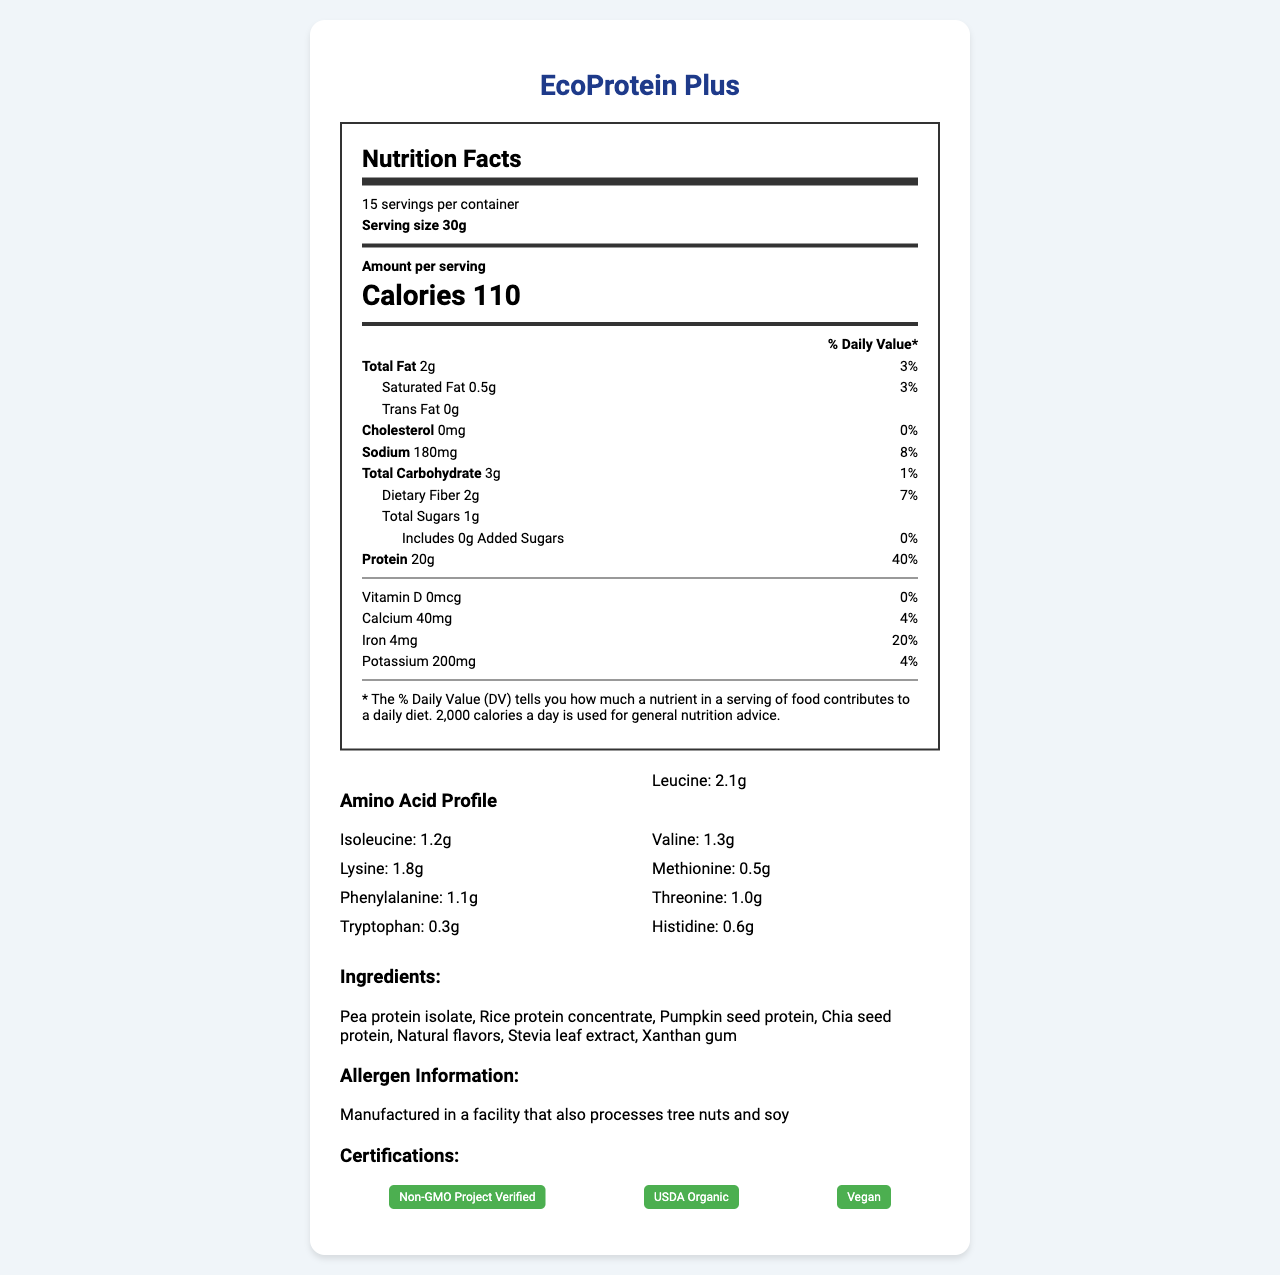what is the serving size of EcoProtein Plus? The serving size is explicitly mentioned on the label as 30g.
Answer: 30g how many servings are there per container? According to the label, there are 15 servings per container.
Answer: 15 how many calories per serving? The label specifies that there are 110 calories per serving.
Answer: 110 what is the amount of protein per serving? The protein amount per serving is stated as 20g on the label.
Answer: 20g how much saturated fat is in one serving? The label indicates that there is 0.5g of saturated fat per serving.
Answer: 0.5g what is the % Daily Value of iron per serving? The Daily Value percentage for iron per serving is listed as 20% on the label.
Answer: 20% what certifications does EcoProtein Plus have? A. USDA Organic, B. Gluten-Free, C. Non-GMO Project Verified, D. Vegan The certifications listed on the label include USDA Organic, Non-GMO Project Verified, and Vegan.
Answer: A, C, D what is the protein digestibility of EcoProtein Plus? A. 89%, B. 75%, C. 92%, D. 85% The digestibility of the protein is noted as 89% in the research notes.
Answer: A is EcoProtein Plus manufactured in a facility that processes soy? The label mentions that it is manufactured in a facility that also processes tree nuts and soy.
Answer: Yes describe the main idea of the document The document outlines the nutritional facts, ingredients, allergen information, and certifications of EcoProtein Plus, while also providing research insights into its protein quality, digestibility, and sustainability.
Answer: The document provides detailed nutritional information for EcoProtein Plus, a plant-based protein powder, including serving size, calorie content, macronutrient distribution, and amino acid profile. It also lists the ingredients, certifications, and research notes on protein quality and sustainability metrics. how does EcoProtein Plus compare to whey protein in terms of water usage? According to the research notes, EcoProtein Plus uses 70% less water than whey protein production.
Answer: 70% less what is the source of sodium in EcoProtein Plus? The document provides the amount of sodium but does not specify its source.
Answer: Cannot be determined what ingredients are in EcoProtein Plus? The label lists these ingredients as part of the product composition.
Answer: Pea protein isolate, Rice protein concentrate, Pumpkin seed protein, Chia seed protein, Natural flavors, Stevia leaf extract, Xanthan gum what is the % Daily Value of calcium in one serving? The Daily Value percentage for calcium per serving is noted as 4% on the label.
Answer: 4% 